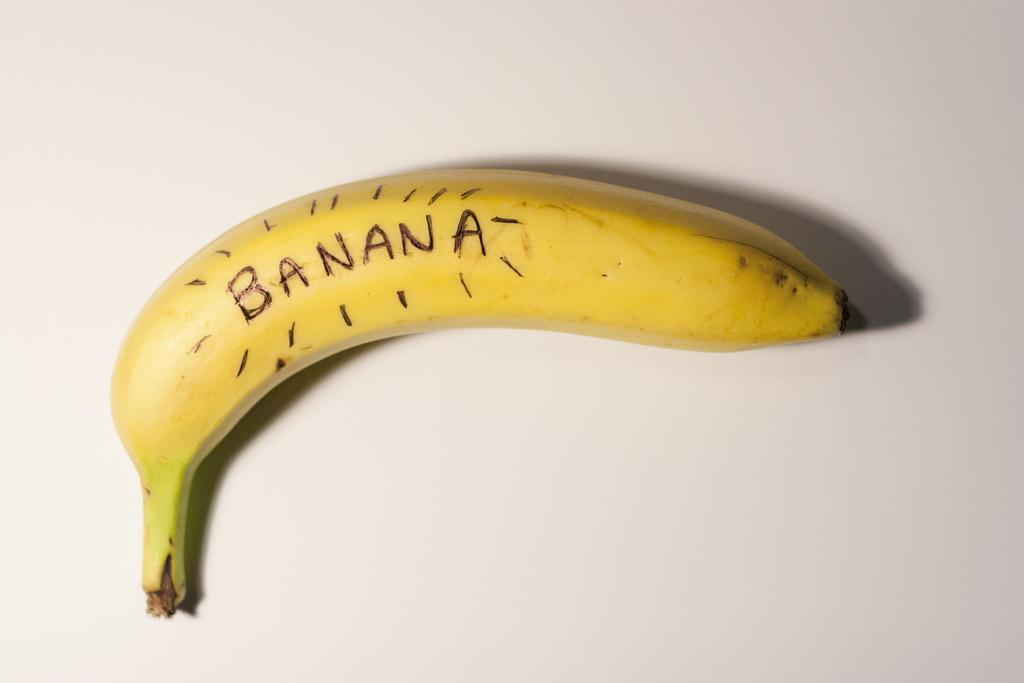<image>
Present a compact description of the photo's key features. A banana is labeled in black marker with the word banana. 